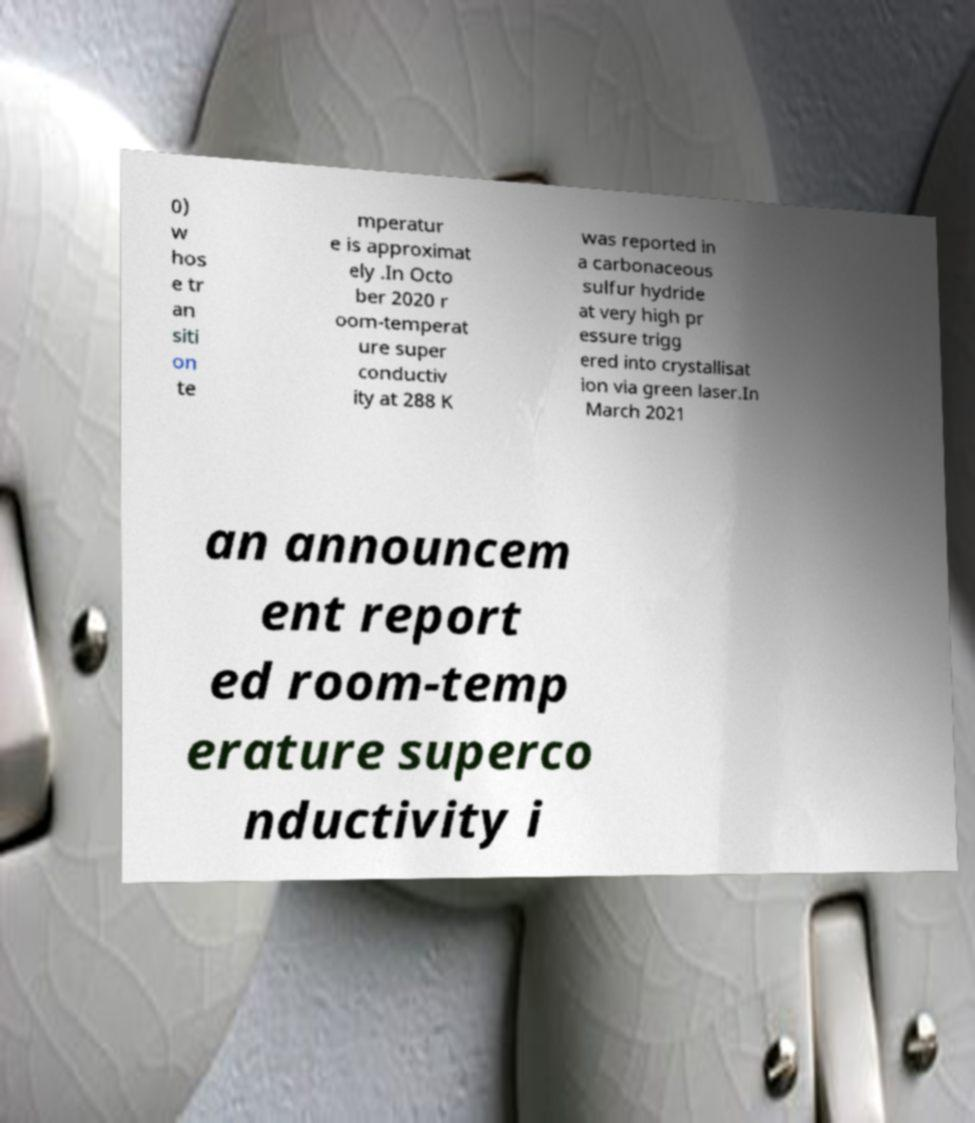What messages or text are displayed in this image? I need them in a readable, typed format. 0) w hos e tr an siti on te mperatur e is approximat ely .In Octo ber 2020 r oom-temperat ure super conductiv ity at 288 K was reported in a carbonaceous sulfur hydride at very high pr essure trigg ered into crystallisat ion via green laser.In March 2021 an announcem ent report ed room-temp erature superco nductivity i 